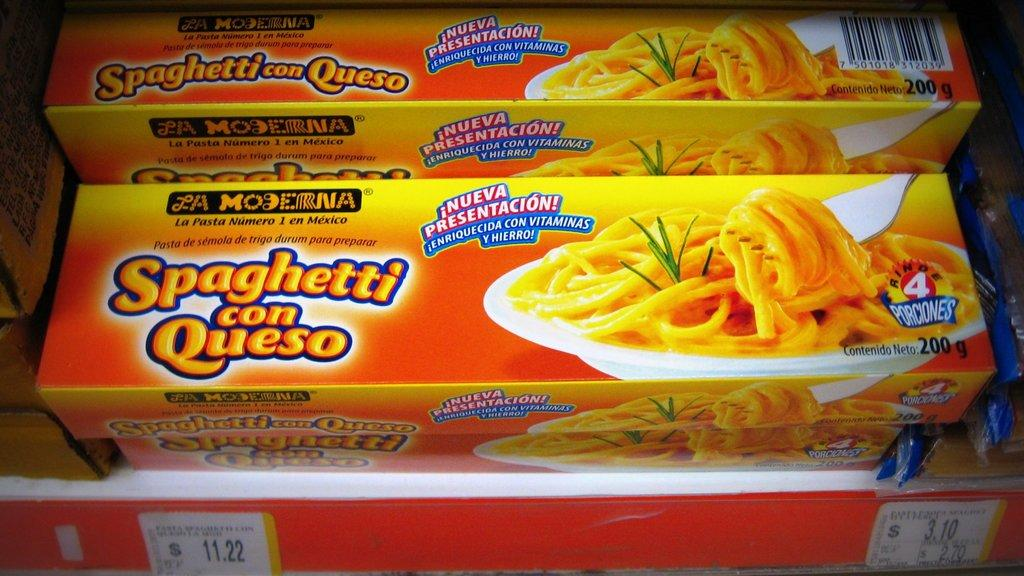What is located in the center of the image? There are banners in the center of the image. What else can be seen in the image besides the banners? There is a table in the image. What is on the table? There are noodle boxes on the table. Can you describe the noodle boxes? There is writing on the noodle boxes. What type of stone can be seen in the image? There is no stone present in the image. Are there any worms visible on the noodle boxes? There are no worms present in the image. 